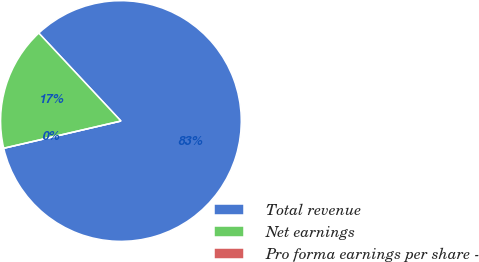<chart> <loc_0><loc_0><loc_500><loc_500><pie_chart><fcel>Total revenue<fcel>Net earnings<fcel>Pro forma earnings per share -<nl><fcel>83.33%<fcel>16.67%<fcel>0.0%<nl></chart> 